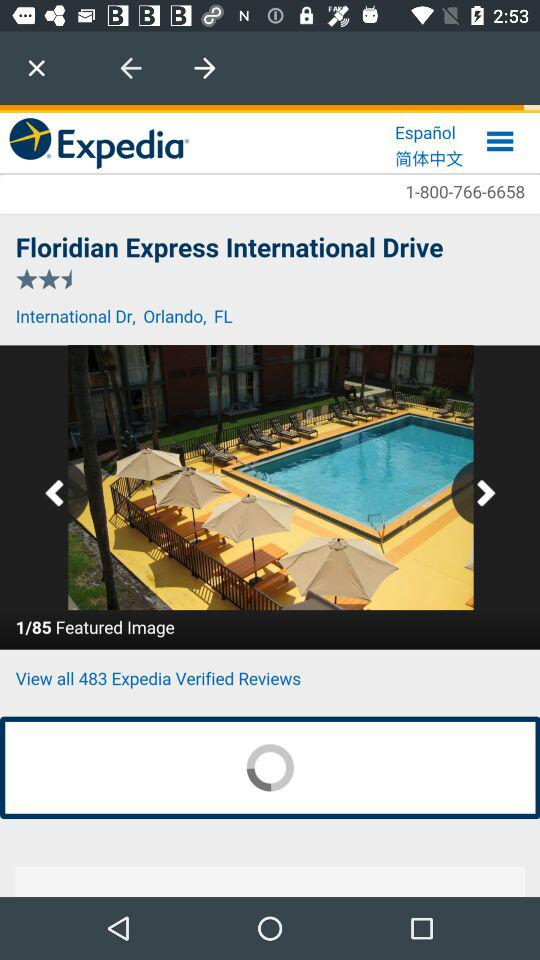How many featured images of the hotel are there? There are 85 featured images. 